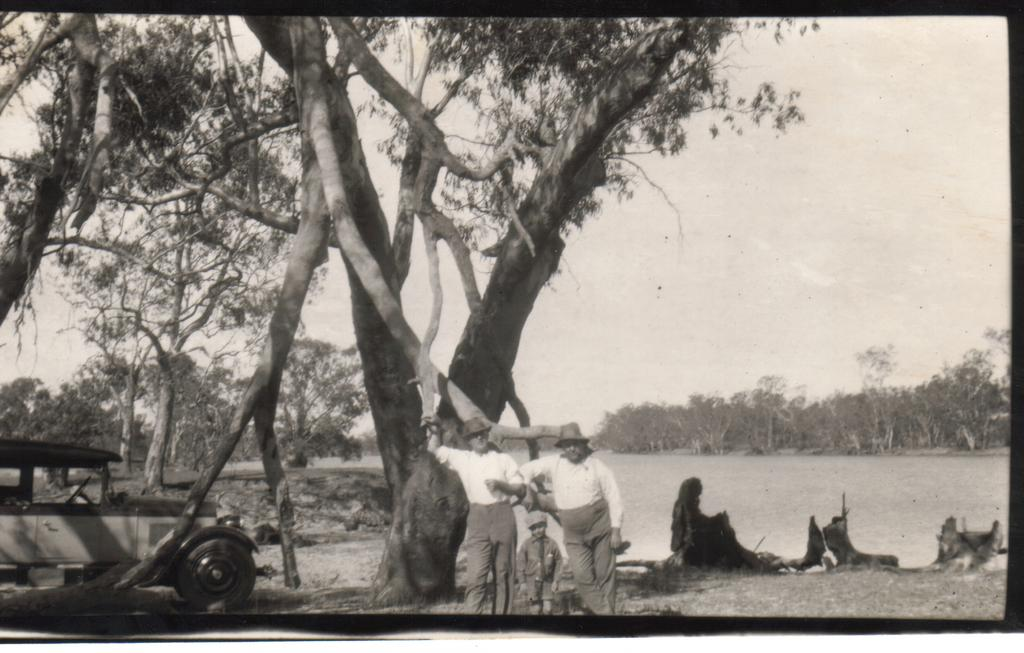What is the color scheme of the image? The image is black and white. How many people are in the image? There are two men and a kid in the image. Where are the people standing in relation to the tree? The people are standing near a tree. What is located beside the tree? There is a car beside the tree. What can be seen in the background of the image? There are trees and a lake visible in the background of the image. What type of poison is the rat carrying in the image? There is no rat or poison present in the image. What is the kid using to eat the food in the image? The image does not show the kid eating or using any utensils, so it cannot be determined from the picture. 